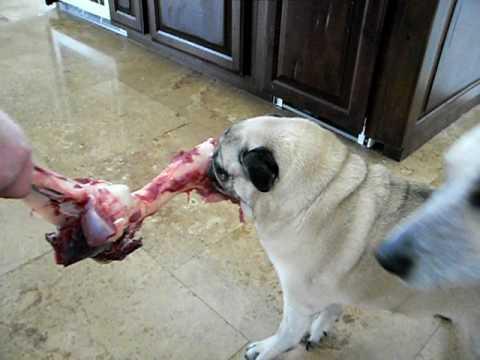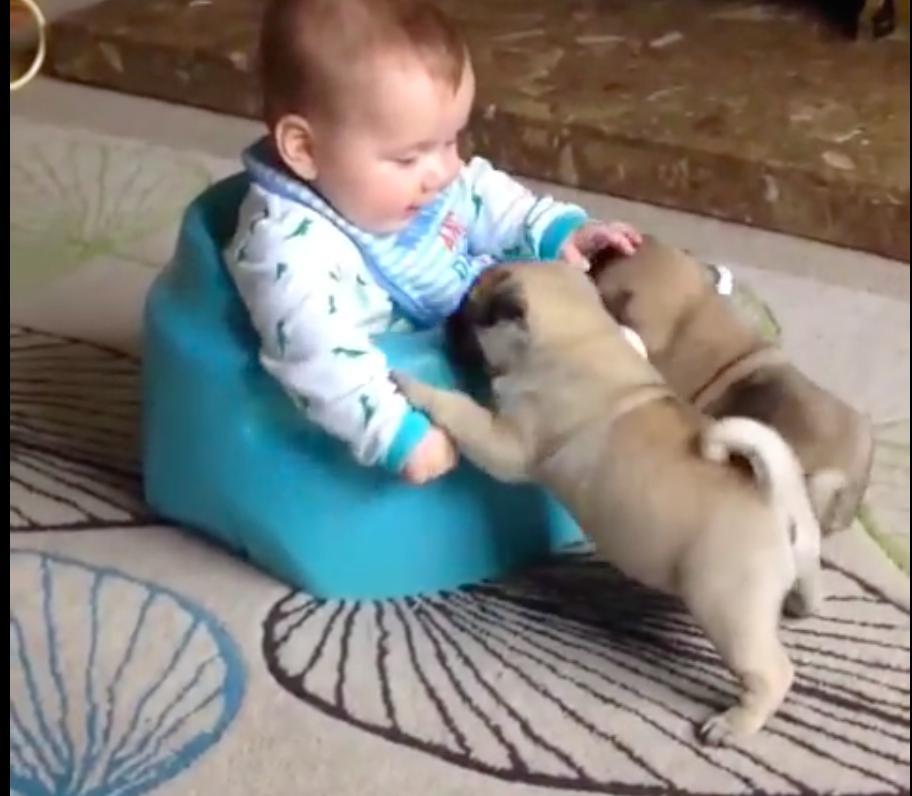The first image is the image on the left, the second image is the image on the right. Examine the images to the left and right. Is the description "Someone is feeding a puppy with a baby bottle in one image, and the other image contains one 'real' pug dog." accurate? Answer yes or no. No. The first image is the image on the left, the second image is the image on the right. Assess this claim about the two images: "In one of the images you can see someone feeding a puppy from a bottle.". Correct or not? Answer yes or no. No. 